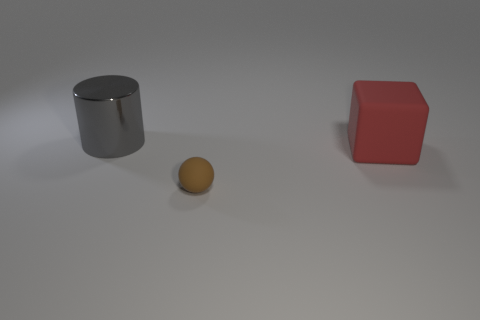Can you describe the lighting and shadows in the scene? The image reveals a single light source, casting soft shadows to the right of the objects. This suggests the light is coming from the top left. The shadows are slightly blurred, lacking hard edges, which hints at the light being diffused rather than direct. 